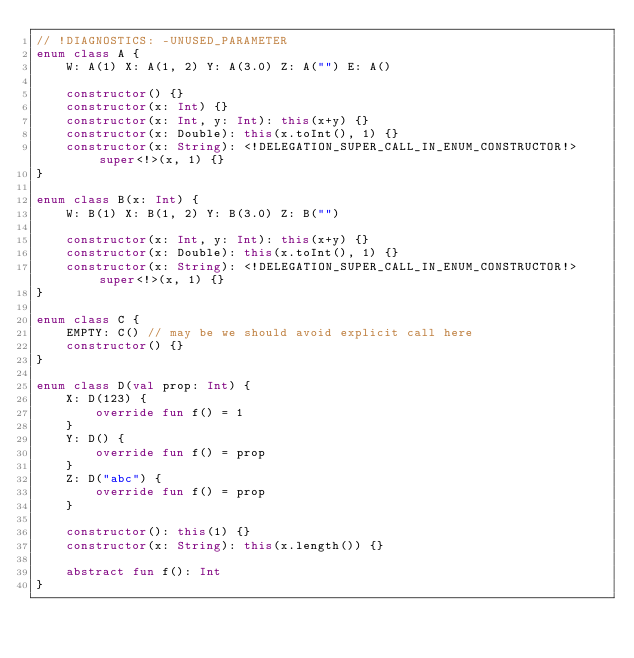Convert code to text. <code><loc_0><loc_0><loc_500><loc_500><_Kotlin_>// !DIAGNOSTICS: -UNUSED_PARAMETER
enum class A {
    W: A(1) X: A(1, 2) Y: A(3.0) Z: A("") E: A()

    constructor() {}
    constructor(x: Int) {}
    constructor(x: Int, y: Int): this(x+y) {}
    constructor(x: Double): this(x.toInt(), 1) {}
    constructor(x: String): <!DELEGATION_SUPER_CALL_IN_ENUM_CONSTRUCTOR!>super<!>(x, 1) {}
}

enum class B(x: Int) {
    W: B(1) X: B(1, 2) Y: B(3.0) Z: B("")

    constructor(x: Int, y: Int): this(x+y) {}
    constructor(x: Double): this(x.toInt(), 1) {}
    constructor(x: String): <!DELEGATION_SUPER_CALL_IN_ENUM_CONSTRUCTOR!>super<!>(x, 1) {}
}

enum class C {
    EMPTY: C() // may be we should avoid explicit call here
    constructor() {}
}

enum class D(val prop: Int) {
    X: D(123) {
        override fun f() = 1
    }
    Y: D() {
        override fun f() = prop
    }
    Z: D("abc") {
        override fun f() = prop
    }

    constructor(): this(1) {}
    constructor(x: String): this(x.length()) {}

    abstract fun f(): Int
}
</code> 